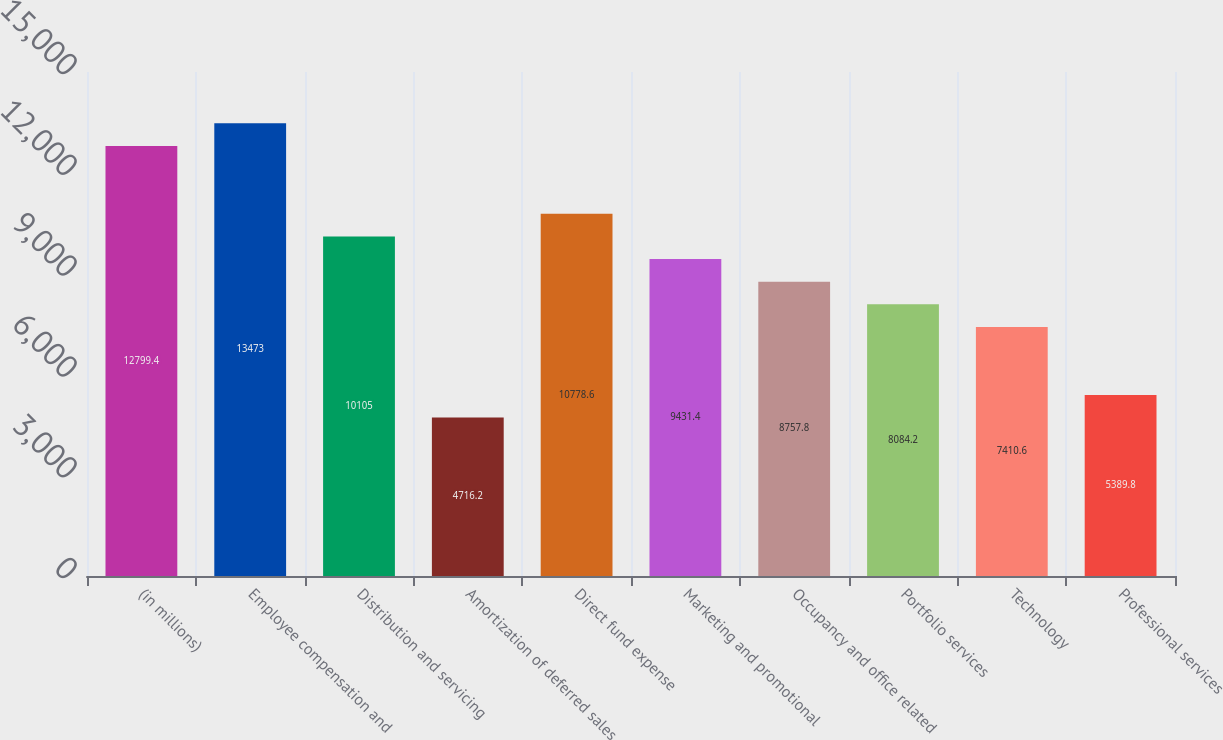<chart> <loc_0><loc_0><loc_500><loc_500><bar_chart><fcel>(in millions)<fcel>Employee compensation and<fcel>Distribution and servicing<fcel>Amortization of deferred sales<fcel>Direct fund expense<fcel>Marketing and promotional<fcel>Occupancy and office related<fcel>Portfolio services<fcel>Technology<fcel>Professional services<nl><fcel>12799.4<fcel>13473<fcel>10105<fcel>4716.2<fcel>10778.6<fcel>9431.4<fcel>8757.8<fcel>8084.2<fcel>7410.6<fcel>5389.8<nl></chart> 